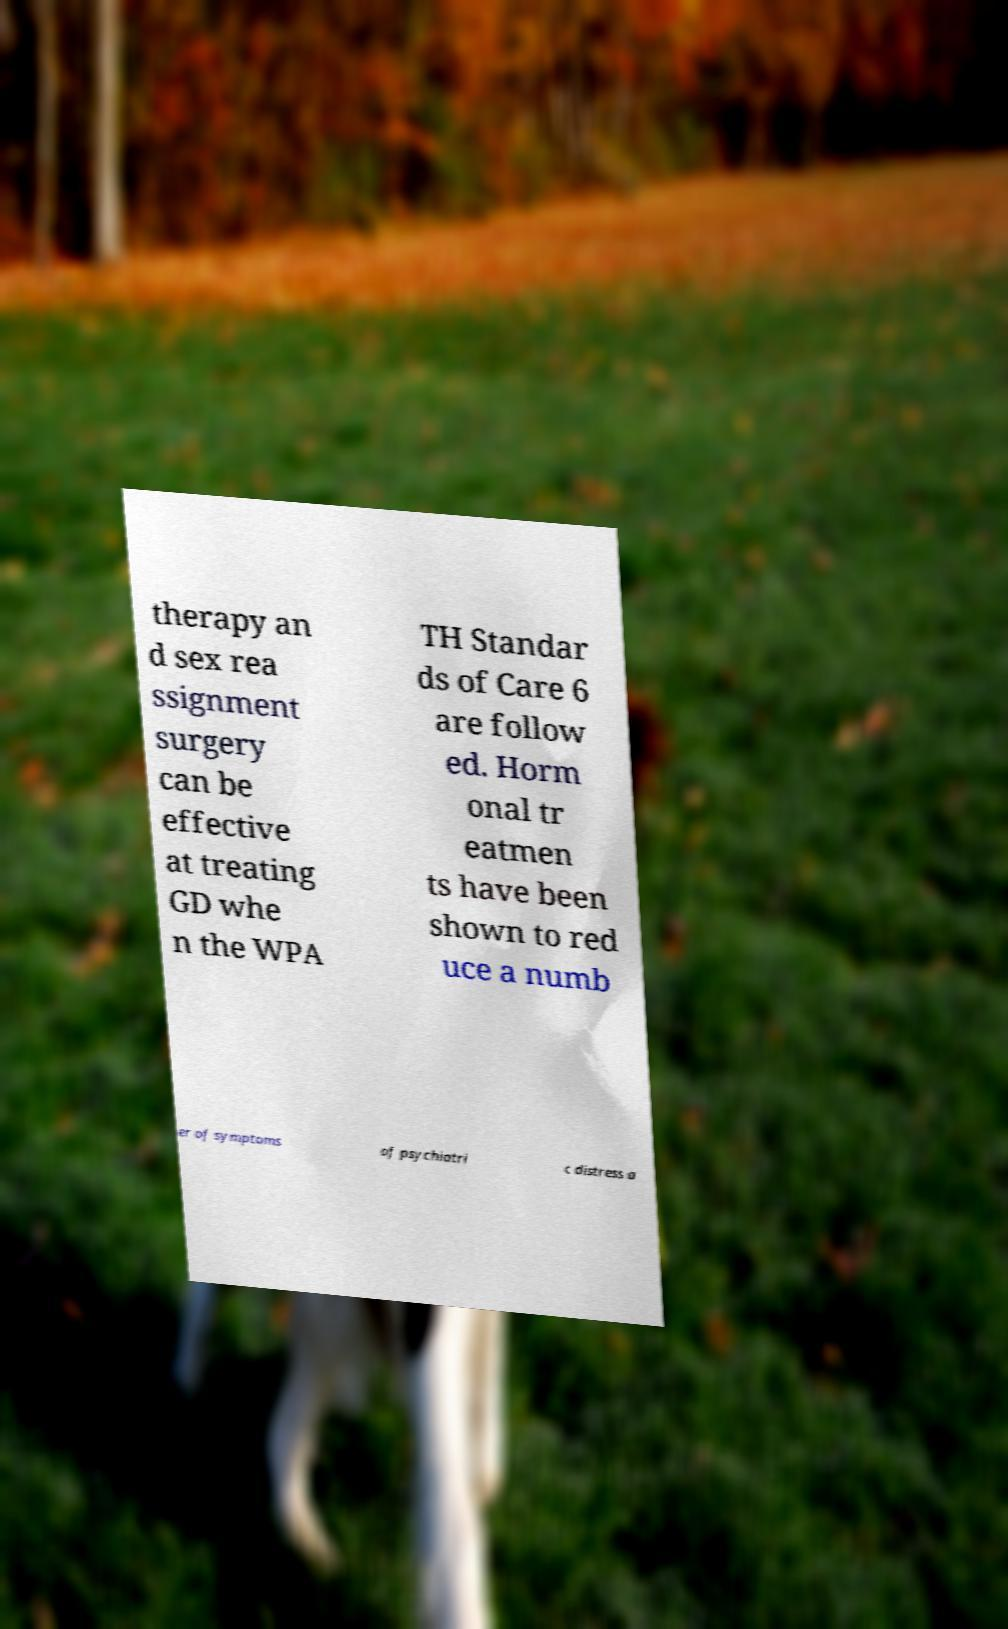For documentation purposes, I need the text within this image transcribed. Could you provide that? therapy an d sex rea ssignment surgery can be effective at treating GD whe n the WPA TH Standar ds of Care 6 are follow ed. Horm onal tr eatmen ts have been shown to red uce a numb er of symptoms of psychiatri c distress a 